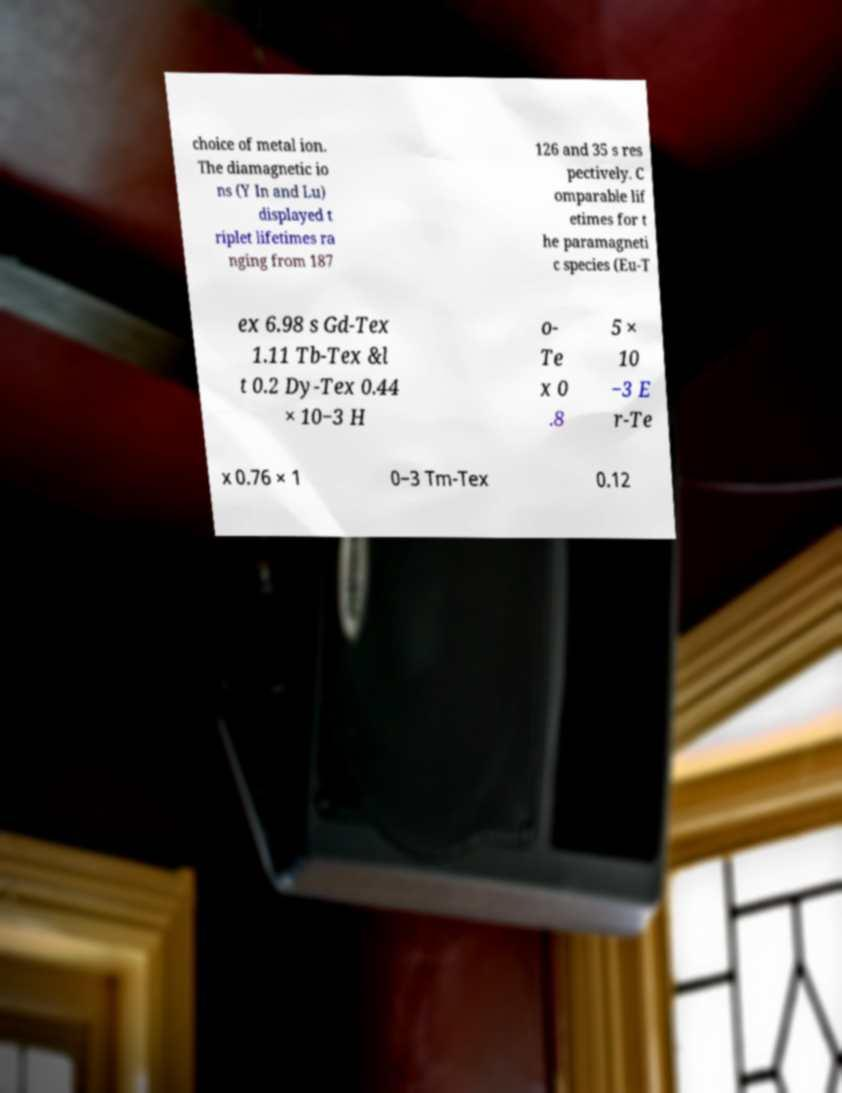Can you read and provide the text displayed in the image?This photo seems to have some interesting text. Can you extract and type it out for me? choice of metal ion. The diamagnetic io ns (Y In and Lu) displayed t riplet lifetimes ra nging from 187 126 and 35 s res pectively. C omparable lif etimes for t he paramagneti c species (Eu-T ex 6.98 s Gd-Tex 1.11 Tb-Tex &l t 0.2 Dy-Tex 0.44 × 10−3 H o- Te x 0 .8 5 × 10 −3 E r-Te x 0.76 × 1 0−3 Tm-Tex 0.12 